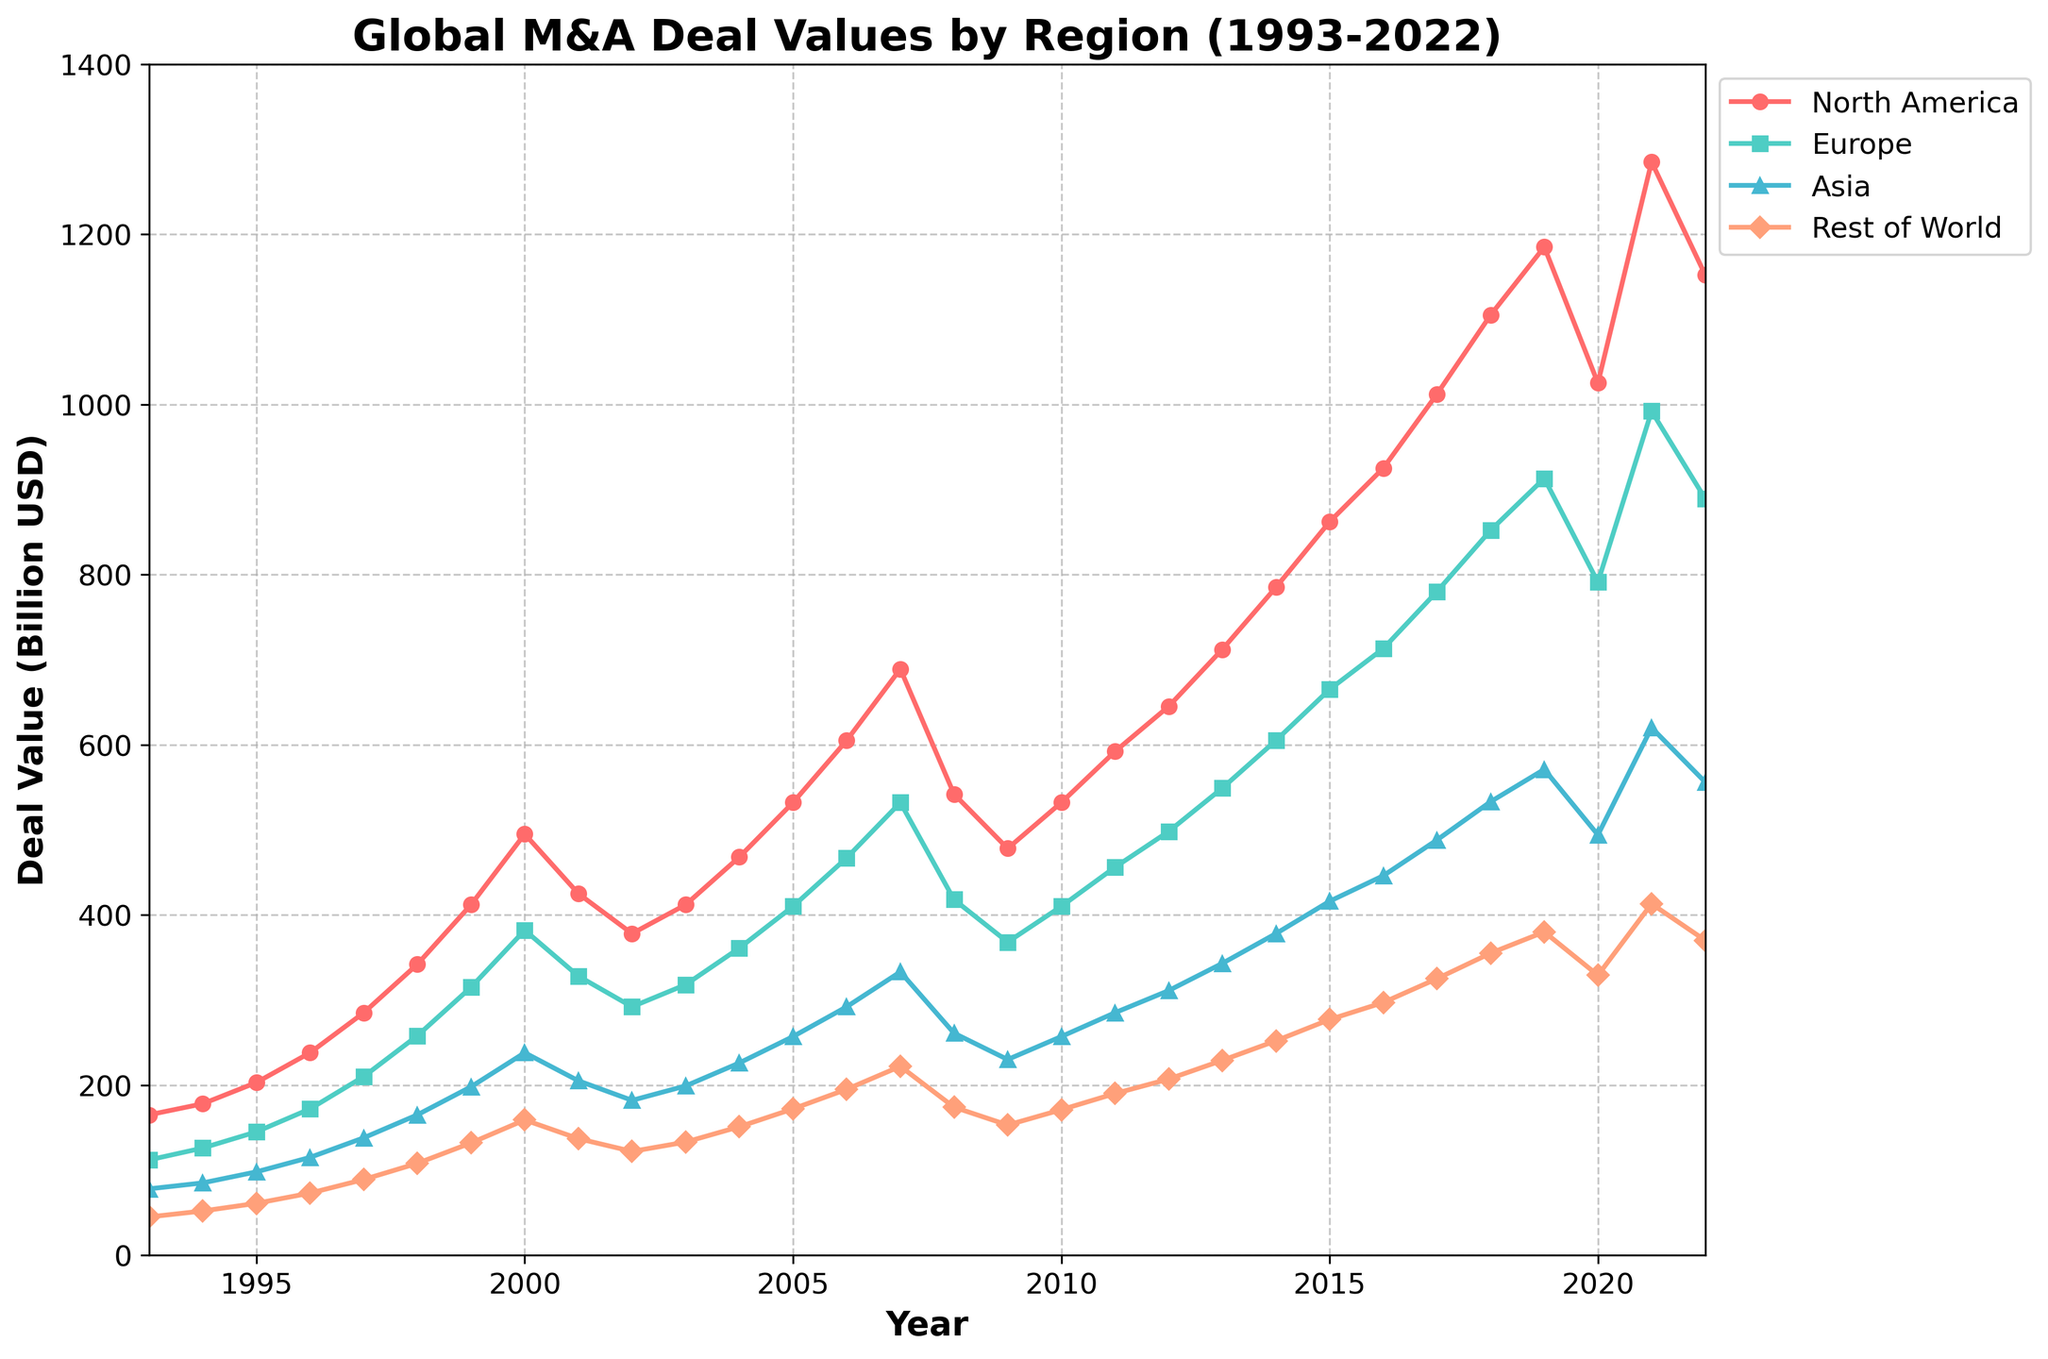What is the total deal value for North America in 2021? To find the total deal value for North America in 2021, look at the value corresponding to the year 2021 under the "North America" column. It is 1285 billion USD.
Answer: 1285 billion USD Which region had the lowest deal value in 1999? To determine which region had the lowest deal value in 1999, compare the numbers for all regions in that year. North America: 412, Europe: 315, Asia: 198, Rest of World: 132. The Rest of the World had the lowest deal value.
Answer: Rest of World How did the deal value for Asia change from 2000 to 2001? To find the change in deal value for Asia from 2000 to 2001, subtract the 2000 value from the 2001 value. 2001 value is 205 and 2000 value is 238. Change = 205 - 238 = -33, so it decreased by 33 billion USD.
Answer: Decreased by 33 billion USD In which year did Europe surpass 500 billion USD in deal value? To identify the year when Europe's deal value surpassed 500 billion USD, find the first year where the value is greater than 500. The value reaches 532 billion USD in 2007.
Answer: 2007 What was the difference in deal values between North America and Europe in 2015? To find the difference, subtract Europe's value from North America's value for 2015. North America: 862, Europe: 665. Difference = 862 - 665 = 197 billion USD.
Answer: 197 billion USD Which region experienced the most significant increase in deal value between 2017 and 2018? Calculate the increase for each region from 2017 to 2018: 
- North America: 1105 - 1012 = 93
- Europe: 852 - 780 = 72
- Asia: 533 - 488 = 45
- Rest of World: 355 - 325 = 30
North America had the most significant increase with 93 billion USD.
Answer: North America What is the average deal value of Asia over the years 2000 to 2010? To find the average, sum up Asia's deal values from 2000 to 2010 and divide by the number of years (11). Sum: 238+205+182+199+226+257+292+333+261+230+257 = 2680. Average = 2680 / 11 = 243.64 billion USD.
Answer: 243.64 billion USD Compare the overall trend between North America and Asia from 1993 to 2022. Visually inspect and compare the lengths of trends in the line chart: North America shows a consistent increase with some fluctuations, peaking around 2021 before a slight decrease in 2022. Asia also shows a general upward trend but at a slower pace and less volatility than North America.
Answer: North America shows a stronger increasing trend with more fluctuations In what year did the Rest of the World reach its peak deal value, and what was the value? To find the peak value, identify the maximum deal value for the Rest of the World and the corresponding year. The peak value is 413 billion USD in 2021.
Answer: 2021, 413 billion USD What kind of pattern do you observe in the deal values for North America after the year 2000? After 2000, North America shows a significant dip in 2008 and 2009 but then recovers and continues to rise with several fluctuations, reaching a peak in 2021 before experiencing a slight decline in 2022.
Answer: Significant dip in 2008-2009, steady recovery, peak in 2021 